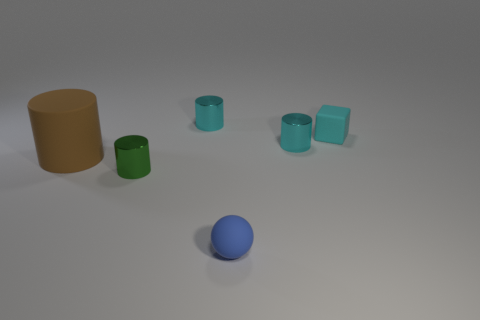Do the matte cylinder and the matte thing in front of the large matte cylinder have the same color?
Provide a short and direct response. No. The brown object that is the same shape as the small green metal object is what size?
Make the answer very short. Large. What shape is the tiny thing that is both to the left of the blue rubber object and behind the large brown cylinder?
Give a very brief answer. Cylinder. There is a matte cylinder; does it have the same size as the matte object in front of the green metallic cylinder?
Give a very brief answer. No. What color is the large rubber object that is the same shape as the green metallic thing?
Give a very brief answer. Brown. There is a shiny cylinder that is on the right side of the tiny blue ball; does it have the same size as the matte thing in front of the matte cylinder?
Your response must be concise. Yes. Is the big brown thing the same shape as the small blue rubber object?
Provide a succinct answer. No. How many objects are cyan shiny cylinders that are behind the cyan matte object or tiny yellow metal cubes?
Offer a very short reply. 1. Are there any tiny cyan things of the same shape as the green object?
Your response must be concise. Yes. Is the number of small cyan cubes left of the matte cylinder the same as the number of tiny spheres?
Offer a very short reply. No. 